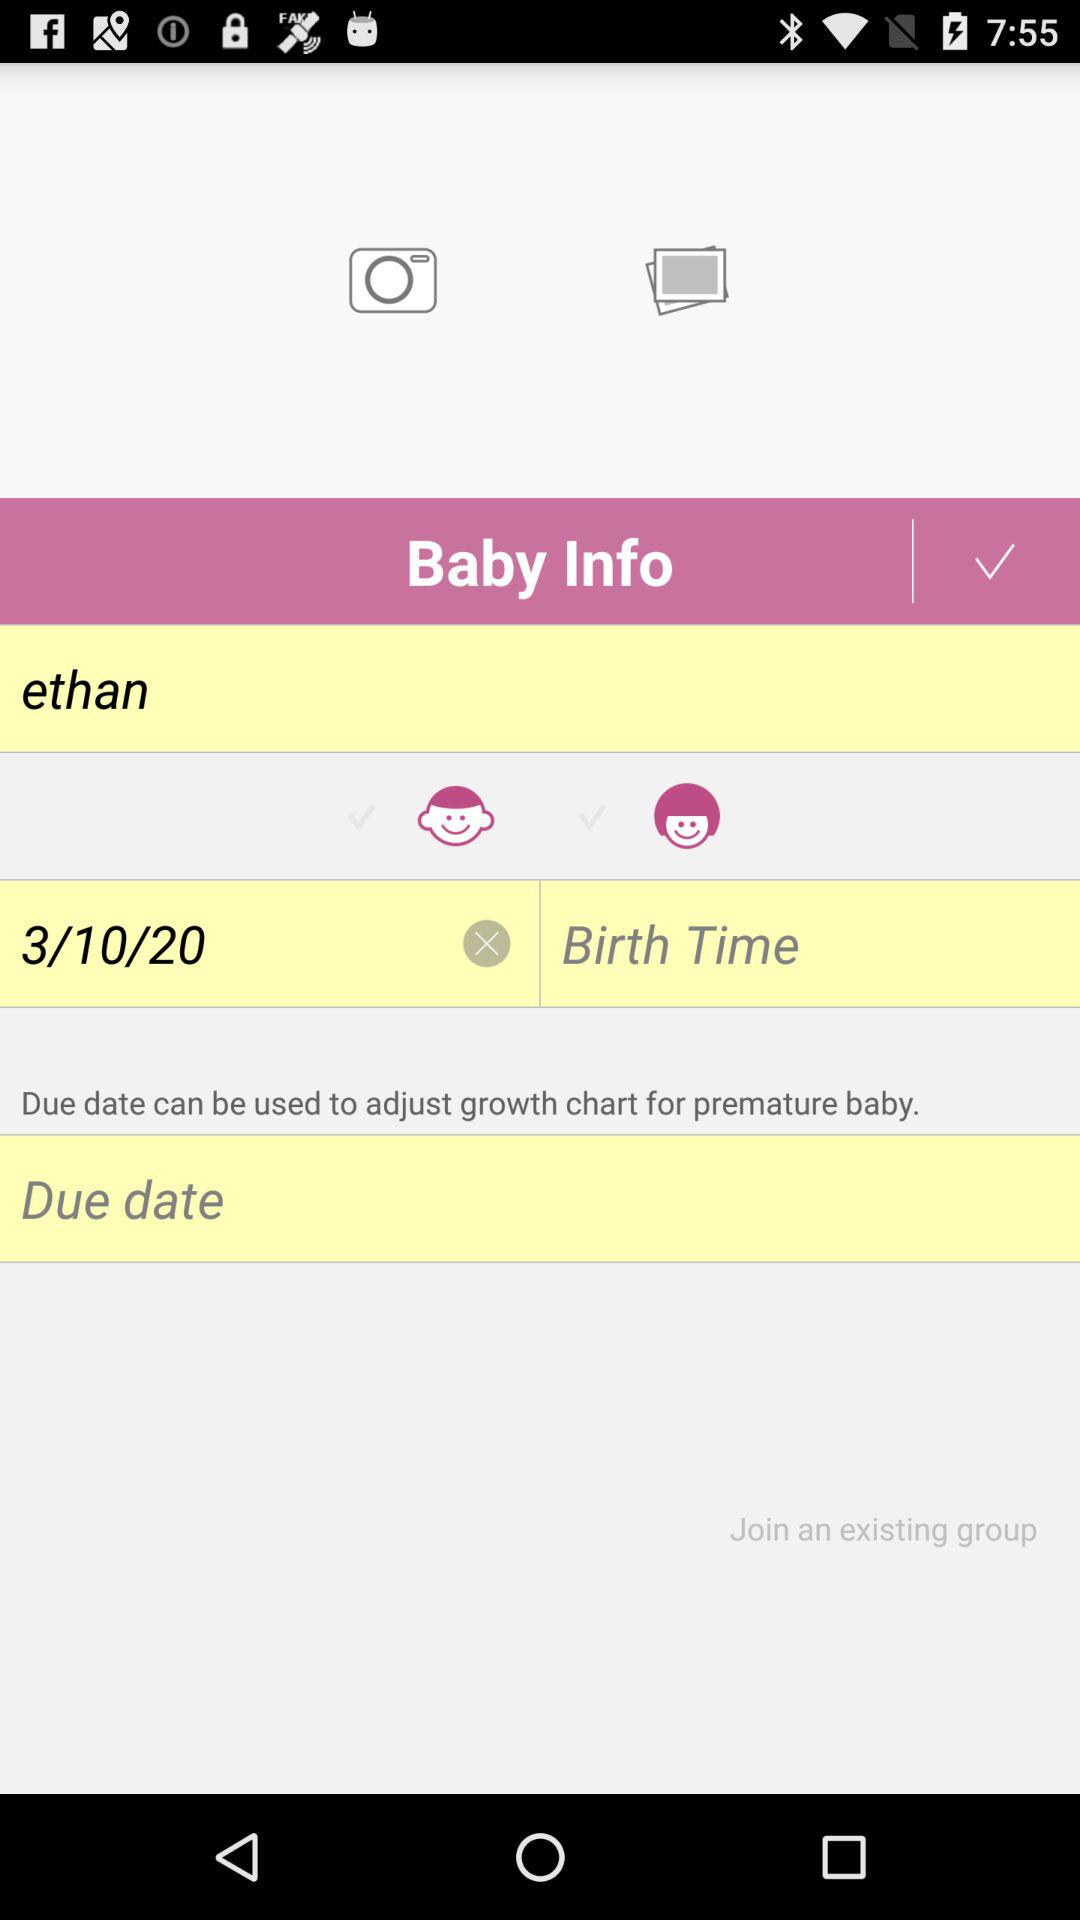What is the baby's name? The baby's name is Ethan. 